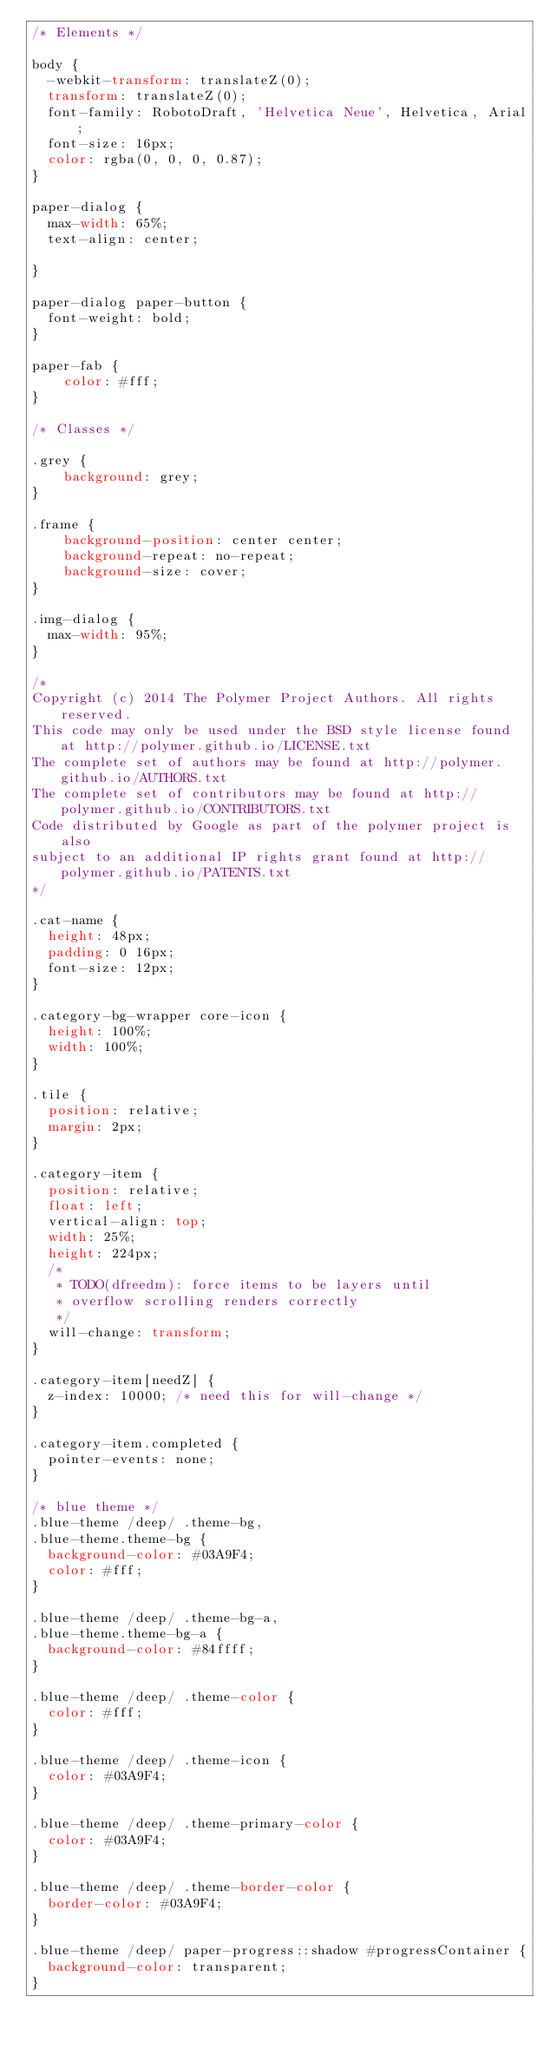<code> <loc_0><loc_0><loc_500><loc_500><_CSS_>/* Elements */

body {
  -webkit-transform: translateZ(0);
  transform: translateZ(0);
  font-family: RobotoDraft, 'Helvetica Neue', Helvetica, Arial;
  font-size: 16px;
  color: rgba(0, 0, 0, 0.87);
}

paper-dialog {
  max-width: 65%;
  text-align: center;

}

paper-dialog paper-button {
  font-weight: bold;
}

paper-fab {
    color: #fff;
}

/* Classes */

.grey {
    background: grey;
}

.frame {
    background-position: center center;
    background-repeat: no-repeat;
    background-size: cover;
}

.img-dialog {
  max-width: 95%;
}

/*
Copyright (c) 2014 The Polymer Project Authors. All rights reserved.
This code may only be used under the BSD style license found at http://polymer.github.io/LICENSE.txt
The complete set of authors may be found at http://polymer.github.io/AUTHORS.txt
The complete set of contributors may be found at http://polymer.github.io/CONTRIBUTORS.txt
Code distributed by Google as part of the polymer project is also
subject to an additional IP rights grant found at http://polymer.github.io/PATENTS.txt
*/

.cat-name {
  height: 48px;
  padding: 0 16px;
  font-size: 12px;
}

.category-bg-wrapper core-icon {
  height: 100%;
  width: 100%;
}

.tile {
  position: relative;
  margin: 2px;
}

.category-item {
  position: relative;
  float: left;
  vertical-align: top;
  width: 25%;
  height: 224px;
  /*
   * TODO(dfreedm): force items to be layers until
   * overflow scrolling renders correctly
   */
  will-change: transform;
}

.category-item[needZ] {
  z-index: 10000; /* need this for will-change */
}

.category-item.completed {
  pointer-events: none;
}

/* blue theme */
.blue-theme /deep/ .theme-bg,
.blue-theme.theme-bg {
  background-color: #03A9F4;
  color: #fff;
}

.blue-theme /deep/ .theme-bg-a,
.blue-theme.theme-bg-a {
  background-color: #84ffff;
}

.blue-theme /deep/ .theme-color {
  color: #fff;
}

.blue-theme /deep/ .theme-icon {
  color: #03A9F4;
}

.blue-theme /deep/ .theme-primary-color {
  color: #03A9F4;
}

.blue-theme /deep/ .theme-border-color {
  border-color: #03A9F4;
}

.blue-theme /deep/ paper-progress::shadow #progressContainer {
  background-color: transparent;
}
</code> 